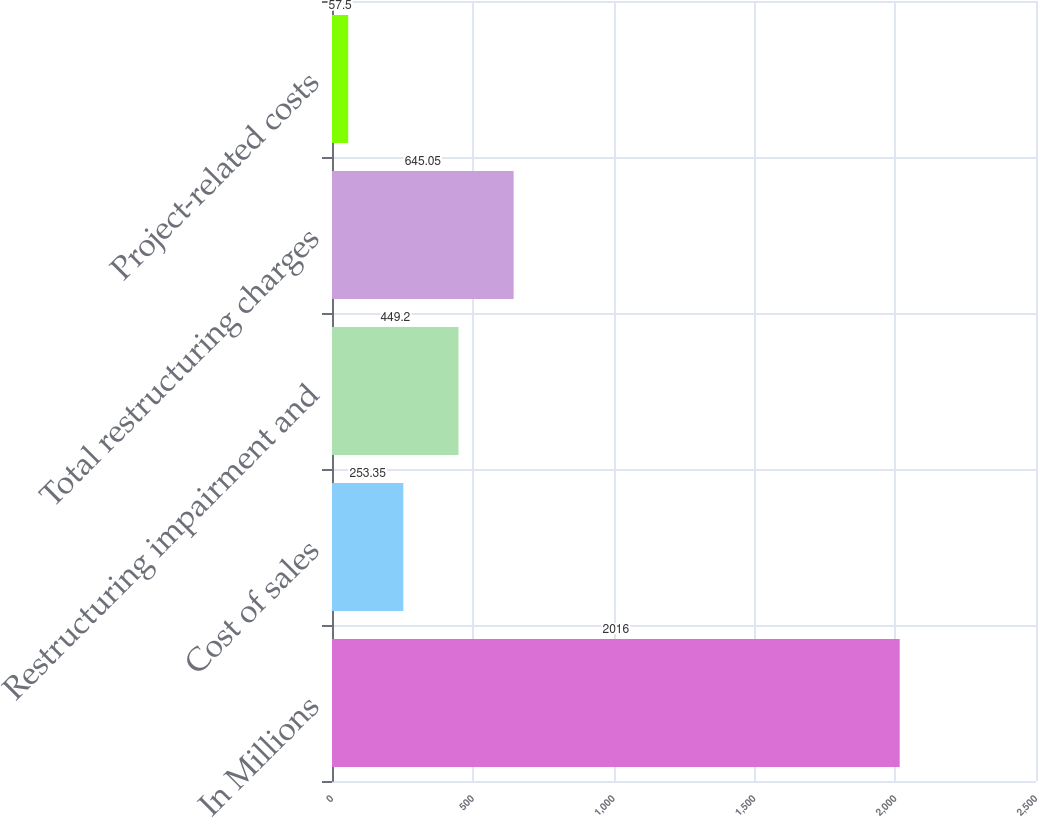<chart> <loc_0><loc_0><loc_500><loc_500><bar_chart><fcel>In Millions<fcel>Cost of sales<fcel>Restructuring impairment and<fcel>Total restructuring charges<fcel>Project-related costs<nl><fcel>2016<fcel>253.35<fcel>449.2<fcel>645.05<fcel>57.5<nl></chart> 